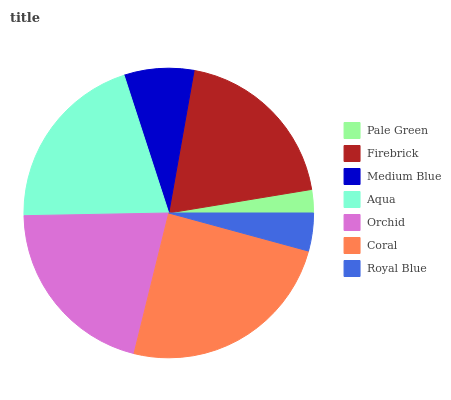Is Pale Green the minimum?
Answer yes or no. Yes. Is Coral the maximum?
Answer yes or no. Yes. Is Firebrick the minimum?
Answer yes or no. No. Is Firebrick the maximum?
Answer yes or no. No. Is Firebrick greater than Pale Green?
Answer yes or no. Yes. Is Pale Green less than Firebrick?
Answer yes or no. Yes. Is Pale Green greater than Firebrick?
Answer yes or no. No. Is Firebrick less than Pale Green?
Answer yes or no. No. Is Firebrick the high median?
Answer yes or no. Yes. Is Firebrick the low median?
Answer yes or no. Yes. Is Coral the high median?
Answer yes or no. No. Is Medium Blue the low median?
Answer yes or no. No. 